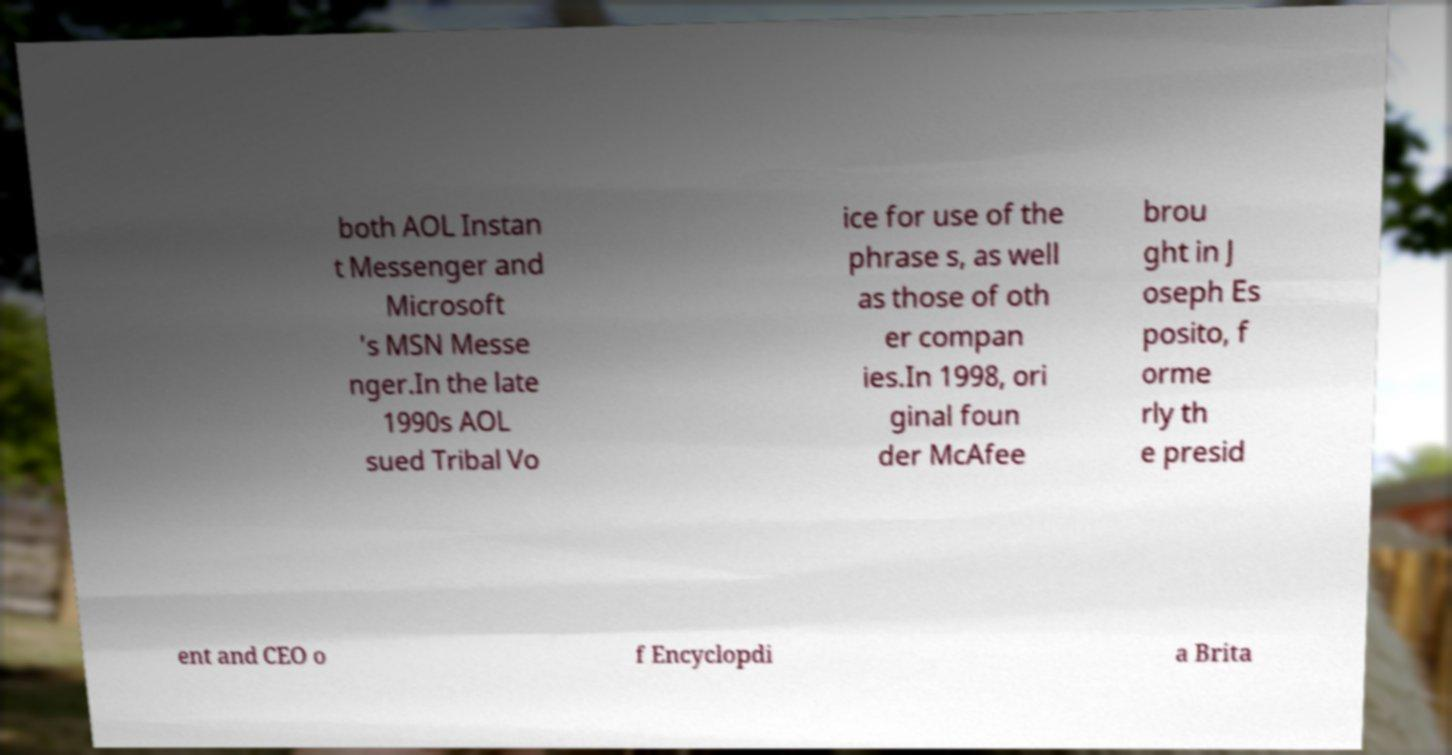Can you accurately transcribe the text from the provided image for me? both AOL Instan t Messenger and Microsoft 's MSN Messe nger.In the late 1990s AOL sued Tribal Vo ice for use of the phrase s, as well as those of oth er compan ies.In 1998, ori ginal foun der McAfee brou ght in J oseph Es posito, f orme rly th e presid ent and CEO o f Encyclopdi a Brita 